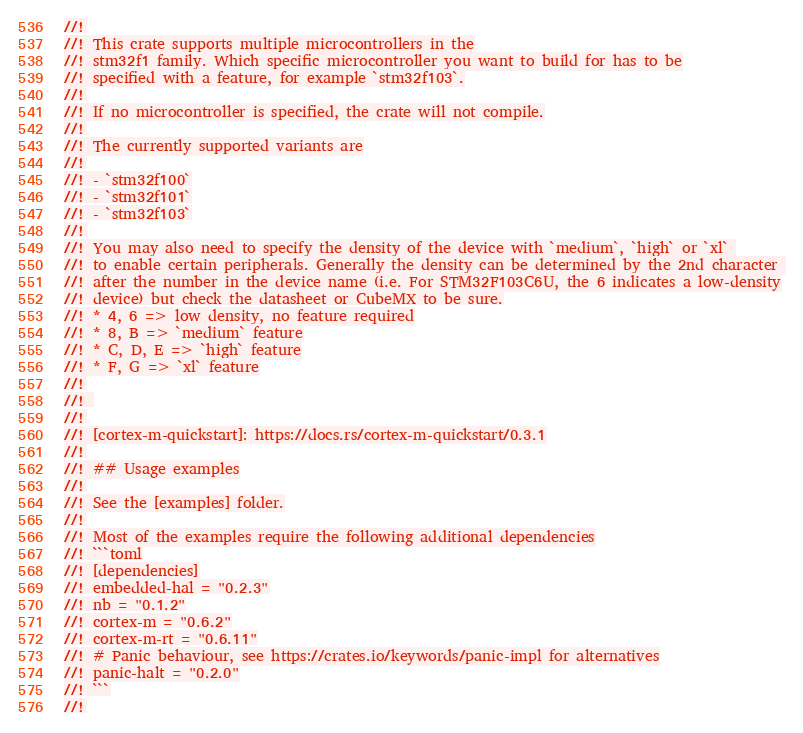Convert code to text. <code><loc_0><loc_0><loc_500><loc_500><_Rust_>//!
//! This crate supports multiple microcontrollers in the
//! stm32f1 family. Which specific microcontroller you want to build for has to be
//! specified with a feature, for example `stm32f103`.
//!
//! If no microcontroller is specified, the crate will not compile.
//!
//! The currently supported variants are
//!
//! - `stm32f100`
//! - `stm32f101`
//! - `stm32f103`
//!
//! You may also need to specify the density of the device with `medium`, `high` or `xl` 
//! to enable certain peripherals. Generally the density can be determined by the 2nd character 
//! after the number in the device name (i.e. For STM32F103C6U, the 6 indicates a low-density
//! device) but check the datasheet or CubeMX to be sure.
//! * 4, 6 => low density, no feature required
//! * 8, B => `medium` feature
//! * C, D, E => `high` feature
//! * F, G => `xl` feature
//!
//! 
//!
//! [cortex-m-quickstart]: https://docs.rs/cortex-m-quickstart/0.3.1
//!
//! ## Usage examples
//!
//! See the [examples] folder.
//!
//! Most of the examples require the following additional dependencies
//! ```toml
//! [dependencies]
//! embedded-hal = "0.2.3"
//! nb = "0.1.2"
//! cortex-m = "0.6.2"
//! cortex-m-rt = "0.6.11"
//! # Panic behaviour, see https://crates.io/keywords/panic-impl for alternatives
//! panic-halt = "0.2.0"
//! ```
//!</code> 